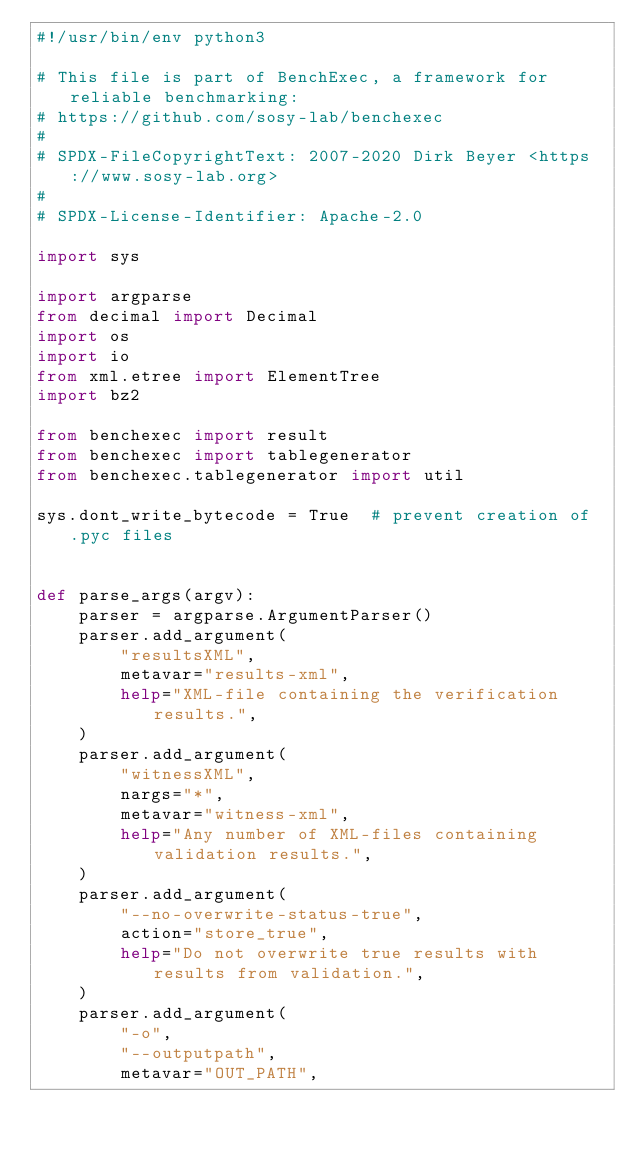Convert code to text. <code><loc_0><loc_0><loc_500><loc_500><_Python_>#!/usr/bin/env python3

# This file is part of BenchExec, a framework for reliable benchmarking:
# https://github.com/sosy-lab/benchexec
#
# SPDX-FileCopyrightText: 2007-2020 Dirk Beyer <https://www.sosy-lab.org>
#
# SPDX-License-Identifier: Apache-2.0

import sys

import argparse
from decimal import Decimal
import os
import io
from xml.etree import ElementTree
import bz2

from benchexec import result
from benchexec import tablegenerator
from benchexec.tablegenerator import util

sys.dont_write_bytecode = True  # prevent creation of .pyc files


def parse_args(argv):
    parser = argparse.ArgumentParser()
    parser.add_argument(
        "resultsXML",
        metavar="results-xml",
        help="XML-file containing the verification results.",
    )
    parser.add_argument(
        "witnessXML",
        nargs="*",
        metavar="witness-xml",
        help="Any number of XML-files containing validation results.",
    )
    parser.add_argument(
        "--no-overwrite-status-true",
        action="store_true",
        help="Do not overwrite true results with results from validation.",
    )
    parser.add_argument(
        "-o",
        "--outputpath",
        metavar="OUT_PATH",</code> 